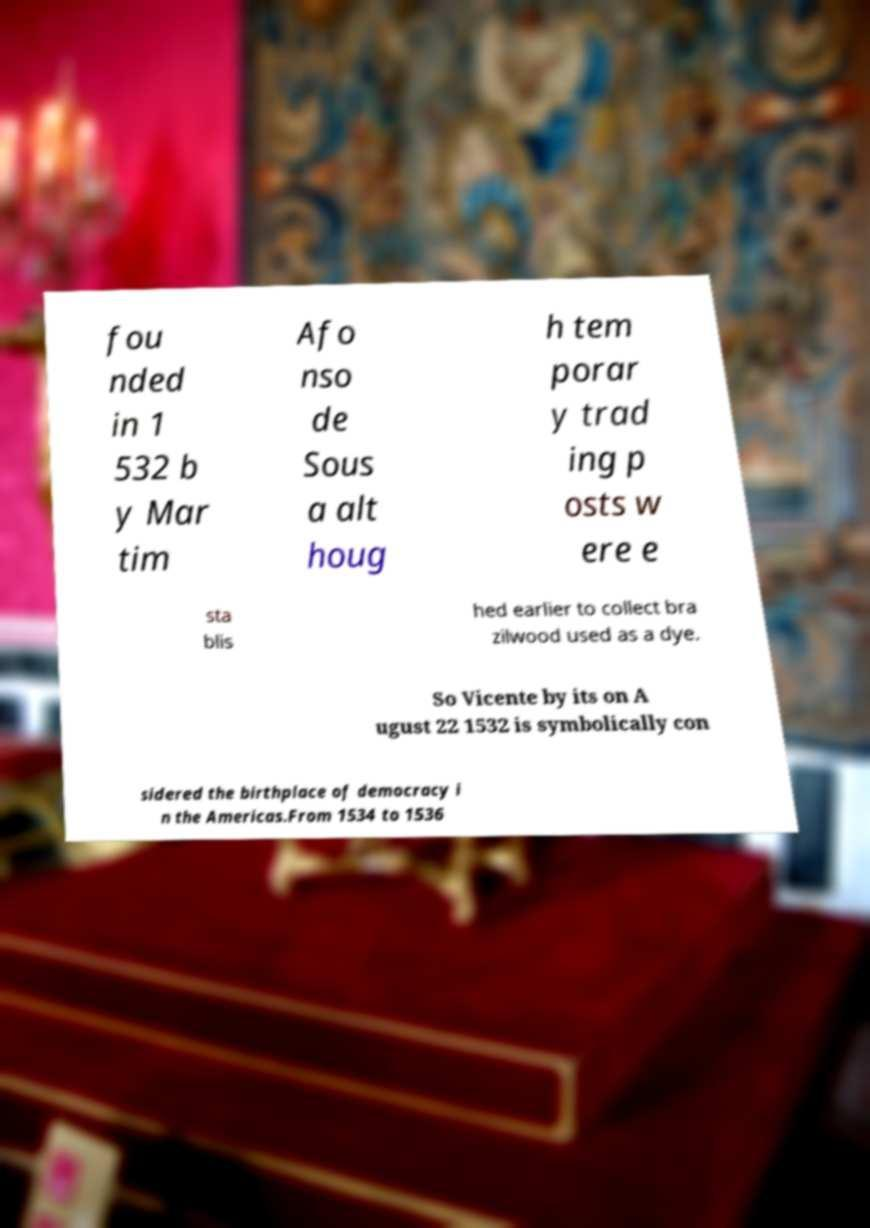There's text embedded in this image that I need extracted. Can you transcribe it verbatim? fou nded in 1 532 b y Mar tim Afo nso de Sous a alt houg h tem porar y trad ing p osts w ere e sta blis hed earlier to collect bra zilwood used as a dye. So Vicente by its on A ugust 22 1532 is symbolically con sidered the birthplace of democracy i n the Americas.From 1534 to 1536 